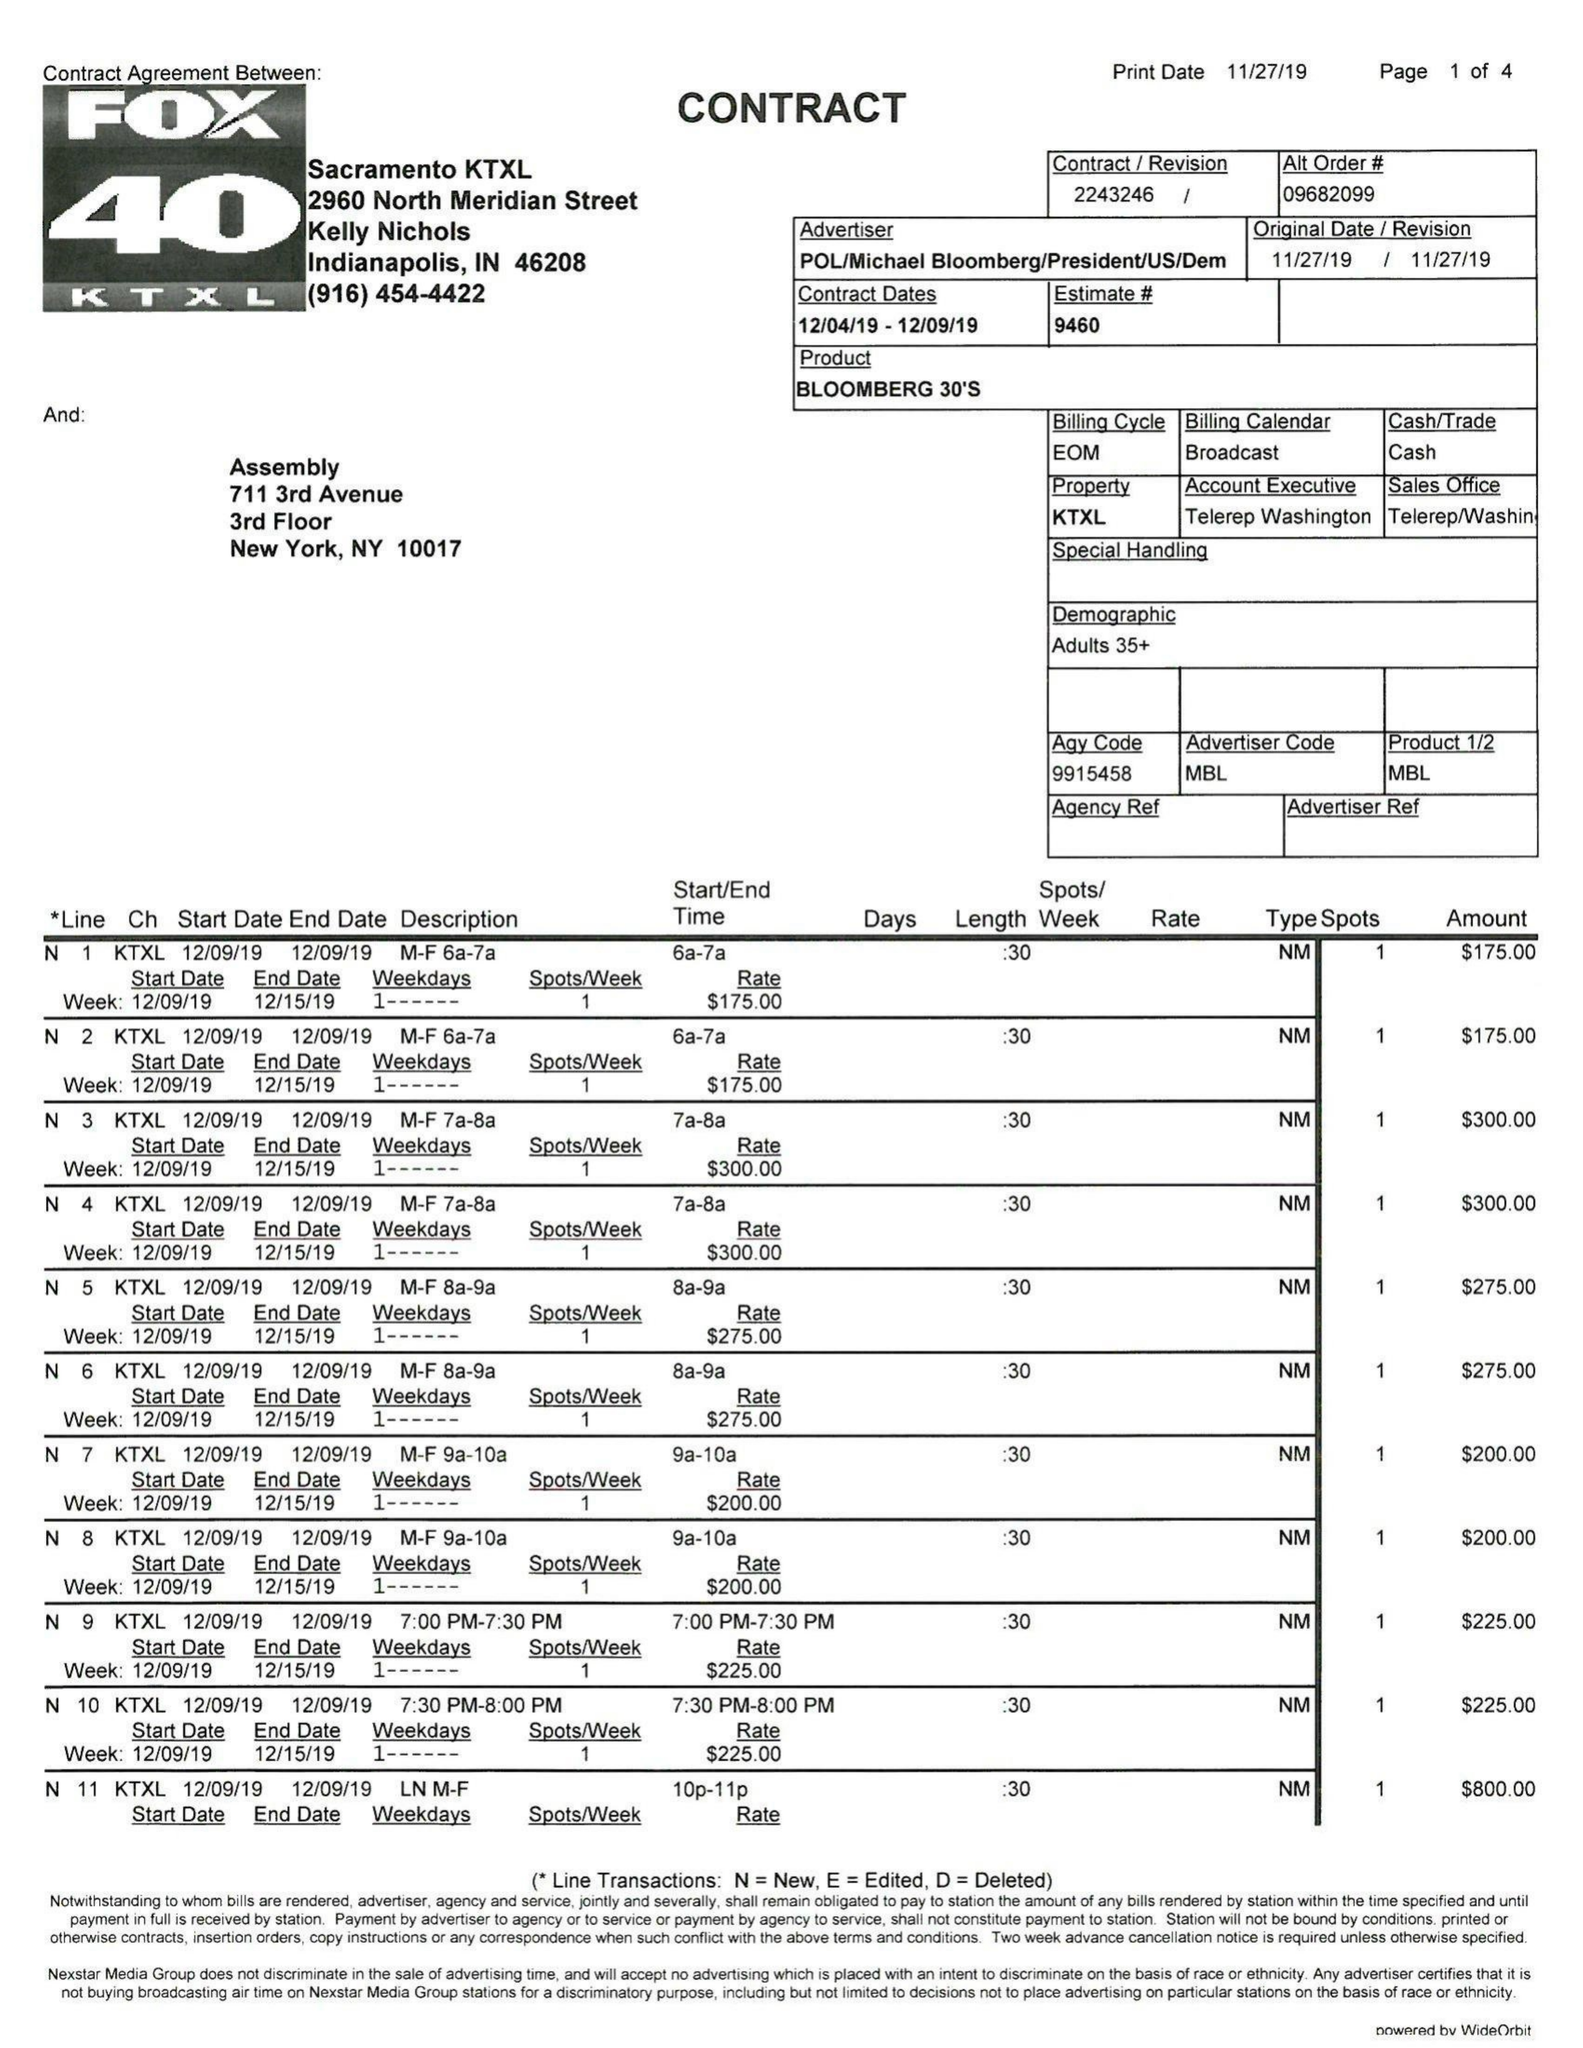What is the value for the advertiser?
Answer the question using a single word or phrase. POL/MICHAELBLOOMBERG/PRESIDEN/US/DEM 